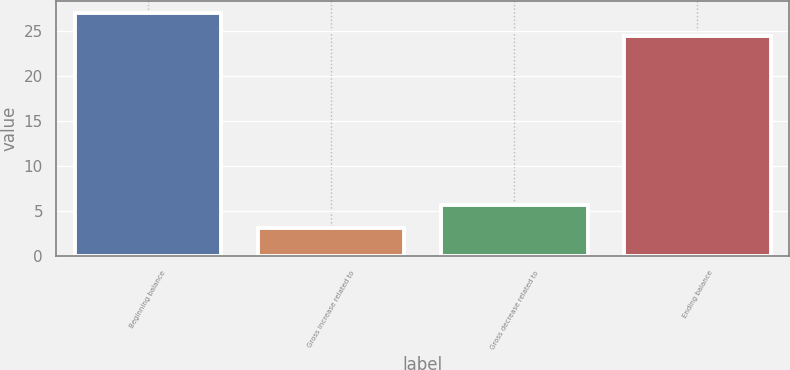Convert chart to OTSL. <chart><loc_0><loc_0><loc_500><loc_500><bar_chart><fcel>Beginning balance<fcel>Gross increase related to<fcel>Gross decrease related to<fcel>Ending balance<nl><fcel>27.01<fcel>3.11<fcel>5.72<fcel>24.4<nl></chart> 